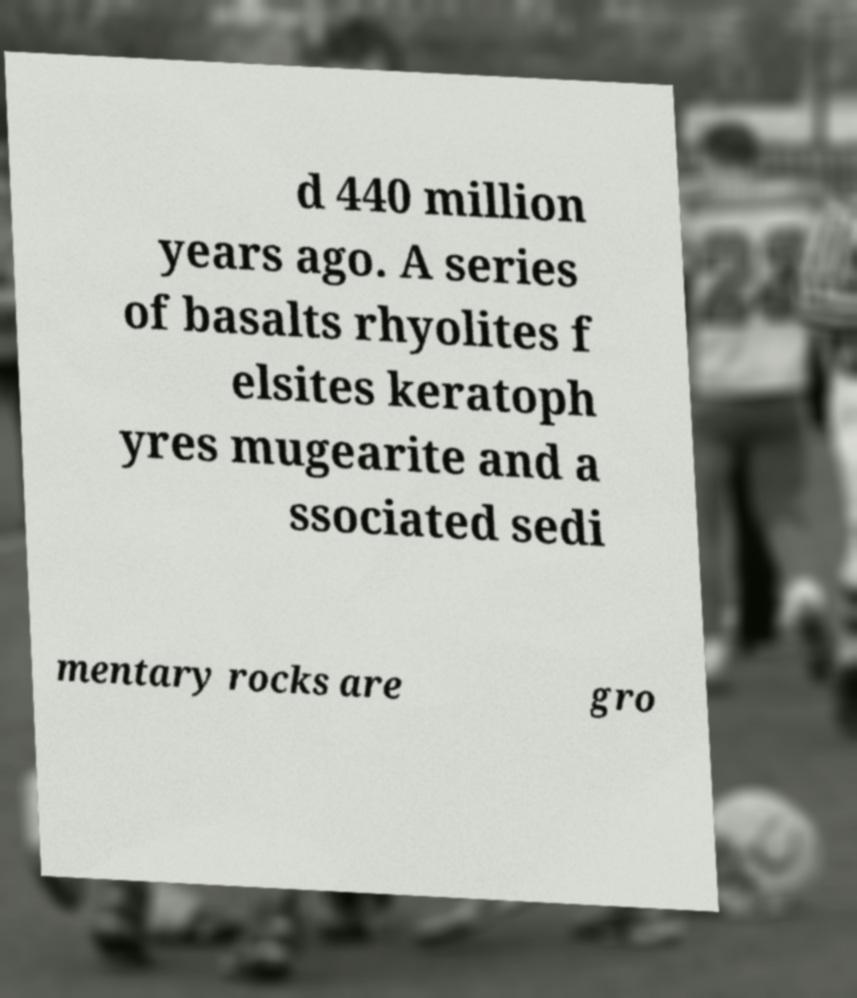Please identify and transcribe the text found in this image. d 440 million years ago. A series of basalts rhyolites f elsites keratoph yres mugearite and a ssociated sedi mentary rocks are gro 